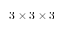Convert formula to latex. <formula><loc_0><loc_0><loc_500><loc_500>3 \times 3 \times 3</formula> 